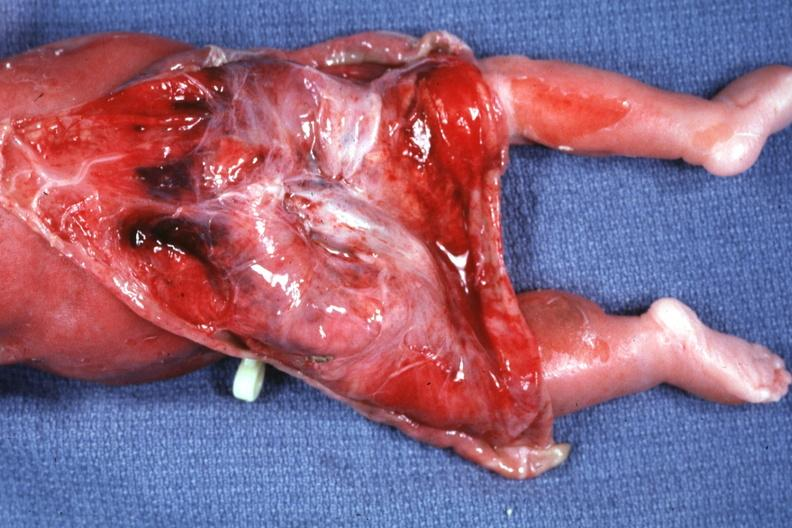what reflected to show large tumor mass?
Answer the question using a single word or phrase. Skin over back a buttocks 